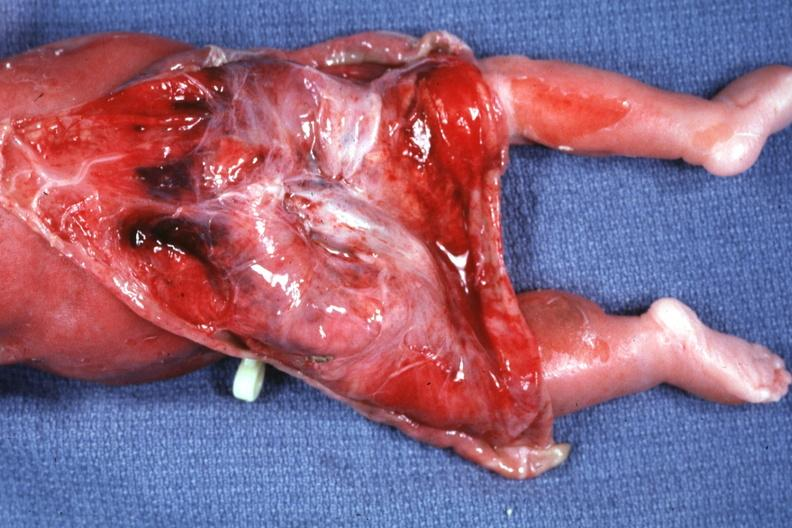what reflected to show large tumor mass?
Answer the question using a single word or phrase. Skin over back a buttocks 